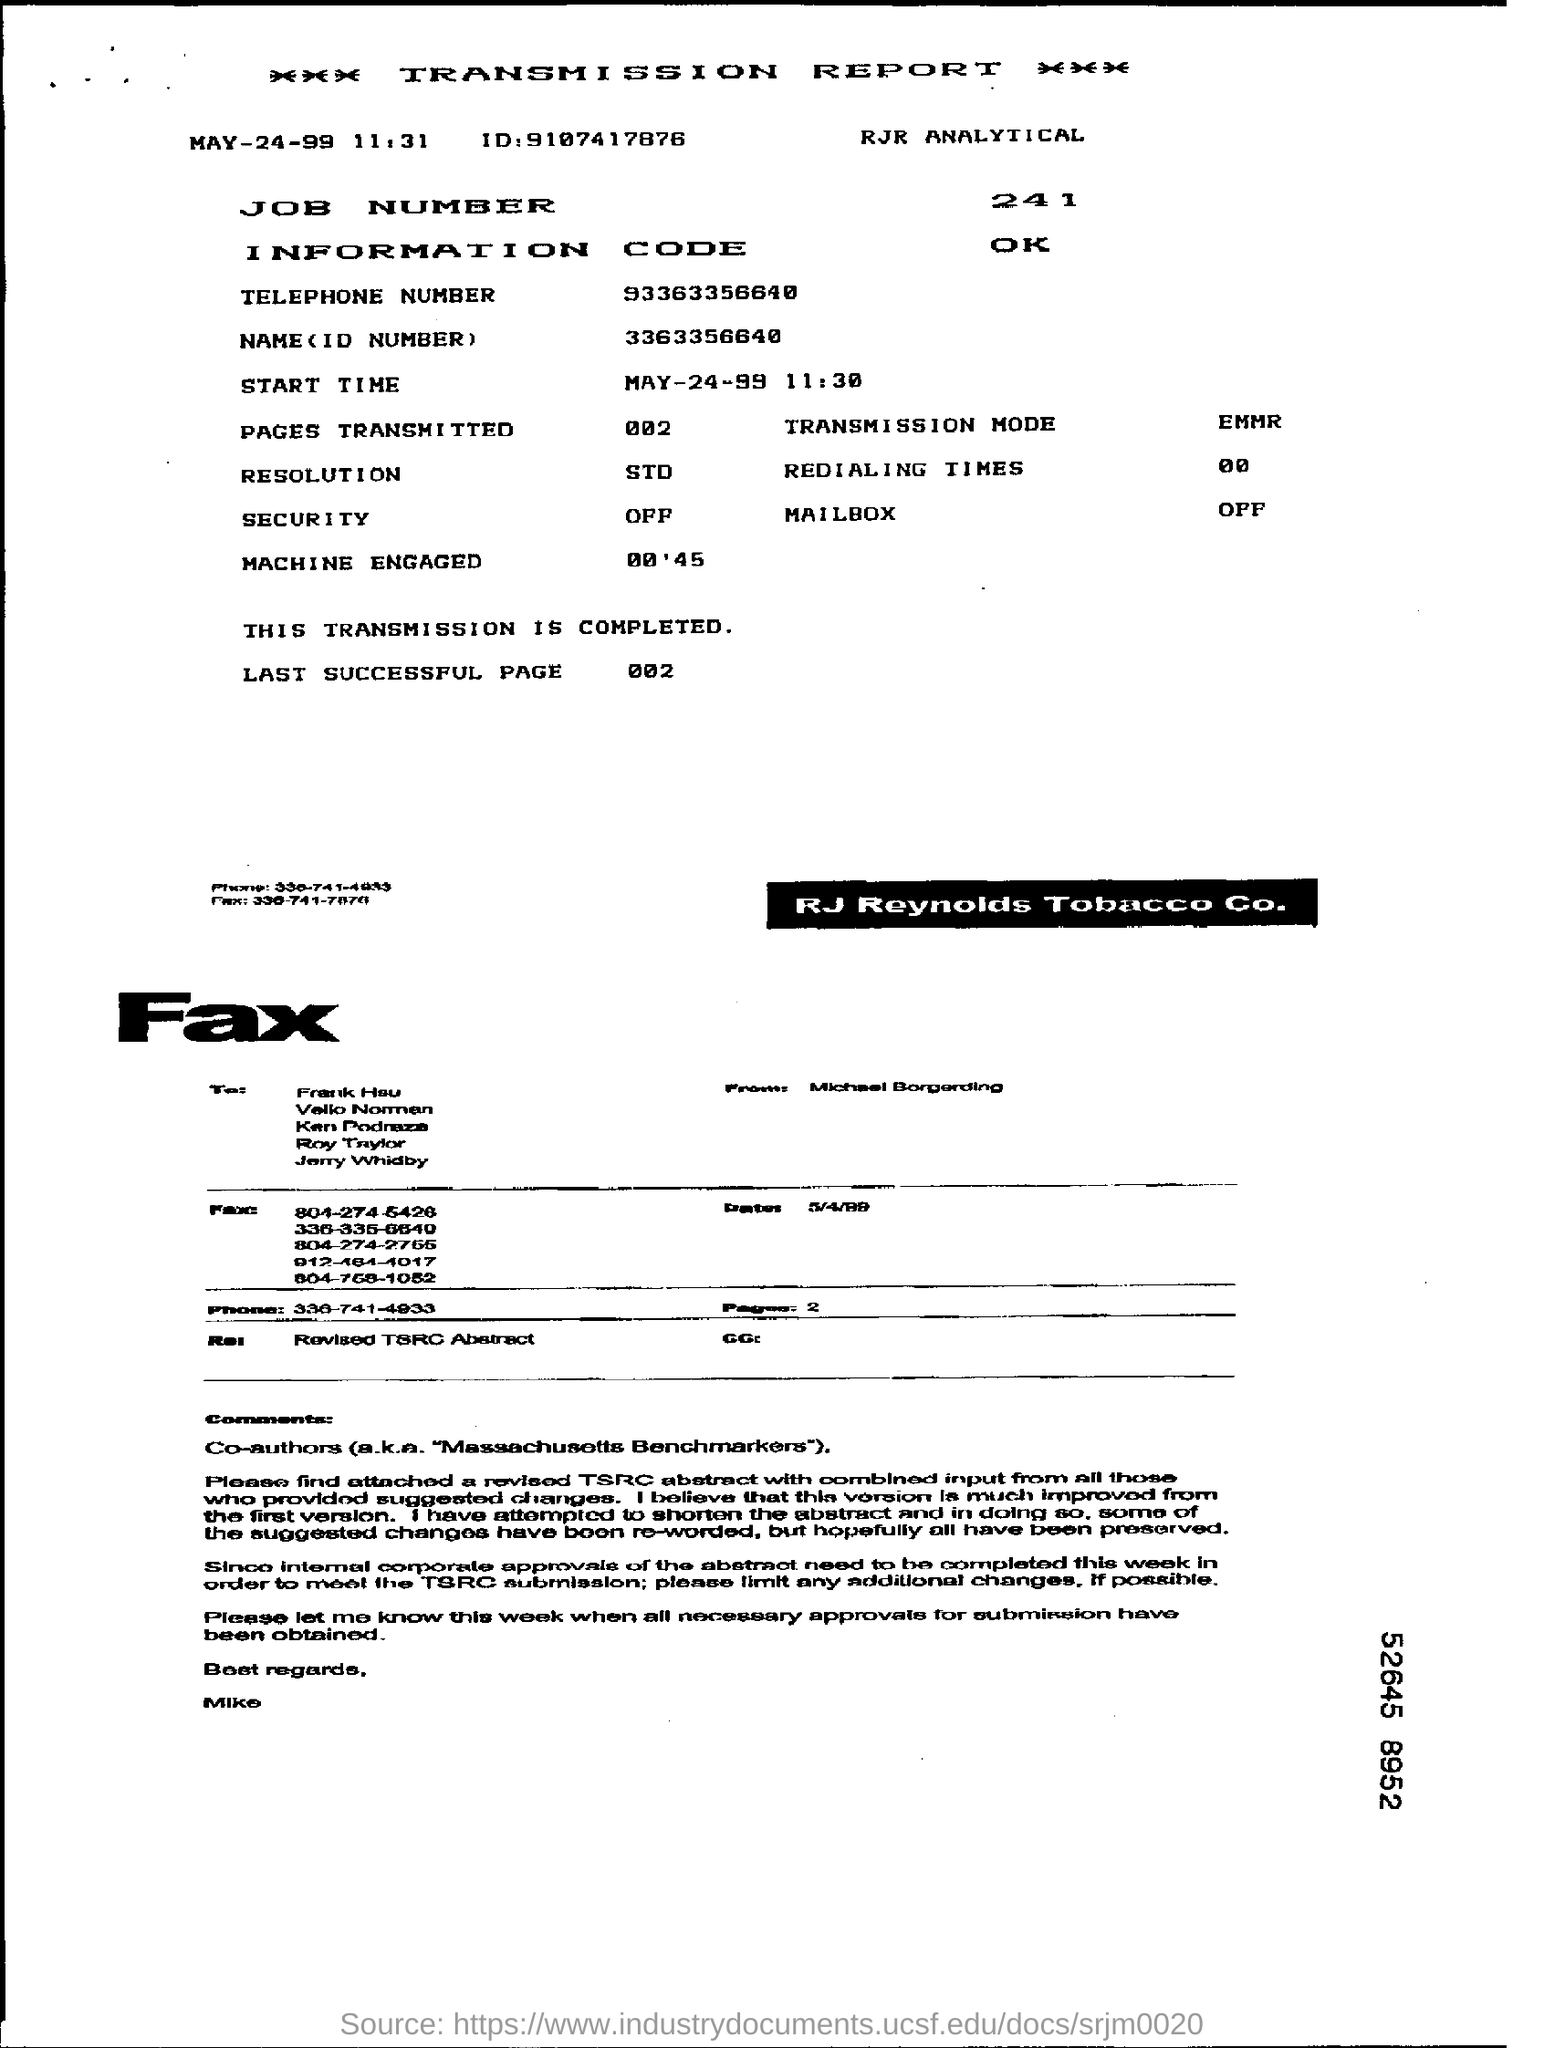What is the START TIME mentioned in the report?
Provide a short and direct response. 11:30. What is the LAST SUCCESSFUL PAGE's number?
Offer a very short reply. 002. 